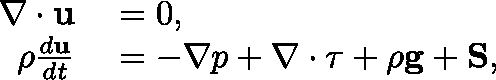Convert formula to latex. <formula><loc_0><loc_0><loc_500><loc_500>\begin{array} { r l } { \nabla \cdot u } & = 0 , } \\ { \rho \frac { d u } { d t } } & = - \nabla p + \nabla \cdot \tau + \rho g + S , } \end{array}</formula> 